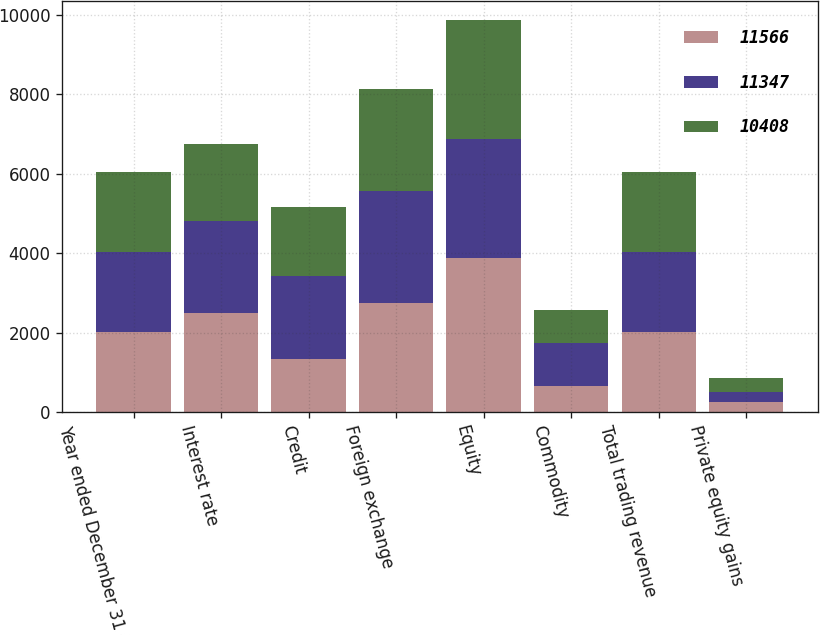Convert chart to OTSL. <chart><loc_0><loc_0><loc_500><loc_500><stacked_bar_chart><ecel><fcel>Year ended December 31 (in<fcel>Interest rate<fcel>Credit<fcel>Foreign exchange<fcel>Equity<fcel>Commodity<fcel>Total trading revenue<fcel>Private equity gains<nl><fcel>11566<fcel>2017<fcel>2479<fcel>1329<fcel>2746<fcel>3873<fcel>661<fcel>2016<fcel>259<nl><fcel>11347<fcel>2016<fcel>2325<fcel>2096<fcel>2827<fcel>2994<fcel>1067<fcel>2016<fcel>257<nl><fcel>10408<fcel>2015<fcel>1933<fcel>1735<fcel>2557<fcel>2990<fcel>842<fcel>2016<fcel>351<nl></chart> 